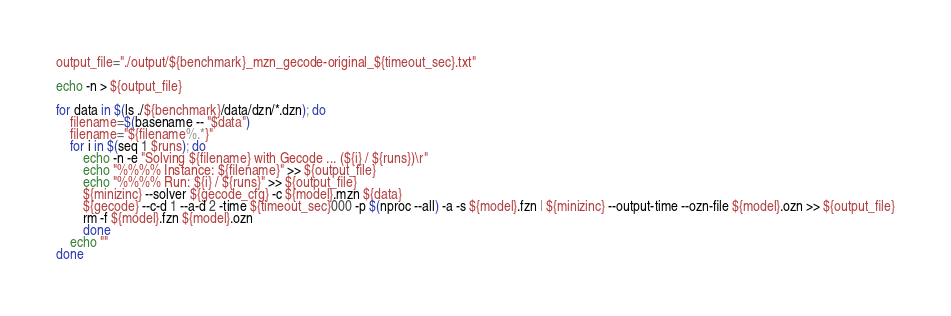Convert code to text. <code><loc_0><loc_0><loc_500><loc_500><_Bash_>output_file="./output/${benchmark}_mzn_gecode-original_${timeout_sec}.txt"

echo -n > ${output_file}

for data in $(ls ./${benchmark}/data/dzn/*.dzn); do
    filename=$(basename -- "$data")
    filename="${filename%.*}"
    for i in $(seq 1 $runs); do  
        echo -n -e "Solving ${filename} with Gecode ... (${i} / ${runs})\r"
        echo "%%%% Instance: ${filename}" >> ${output_file}
        echo "%%%% Run: ${i} / ${runs}" >> ${output_file}
        ${minizinc} --solver ${gecode_cfg} -c ${model}.mzn ${data}
        ${gecode} --c-d 1 --a-d 2 -time ${timeout_sec}000 -p $(nproc --all) -a -s ${model}.fzn | ${minizinc} --output-time --ozn-file ${model}.ozn >> ${output_file}
        rm -f ${model}.fzn ${model}.ozn
        done
    echo ""
done
</code> 